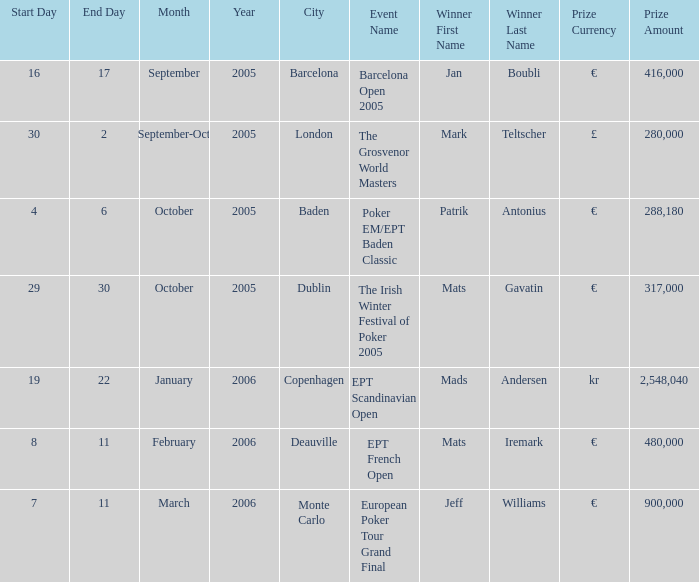What event did Mark Teltscher win? The Grosvenor World Masters. 